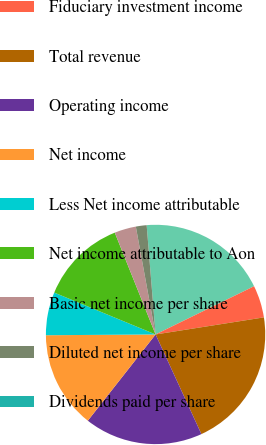Convert chart. <chart><loc_0><loc_0><loc_500><loc_500><pie_chart><fcel>Commissions fees and other<fcel>Fiduciary investment income<fcel>Total revenue<fcel>Operating income<fcel>Net income<fcel>Less Net income attributable<fcel>Net income attributable to Aon<fcel>Basic net income per share<fcel>Diluted net income per share<fcel>Dividends paid per share<nl><fcel>19.05%<fcel>4.76%<fcel>20.63%<fcel>17.46%<fcel>14.29%<fcel>6.35%<fcel>12.7%<fcel>3.18%<fcel>1.59%<fcel>0.0%<nl></chart> 